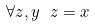Convert formula to latex. <formula><loc_0><loc_0><loc_500><loc_500>\forall z , y \ z = x</formula> 